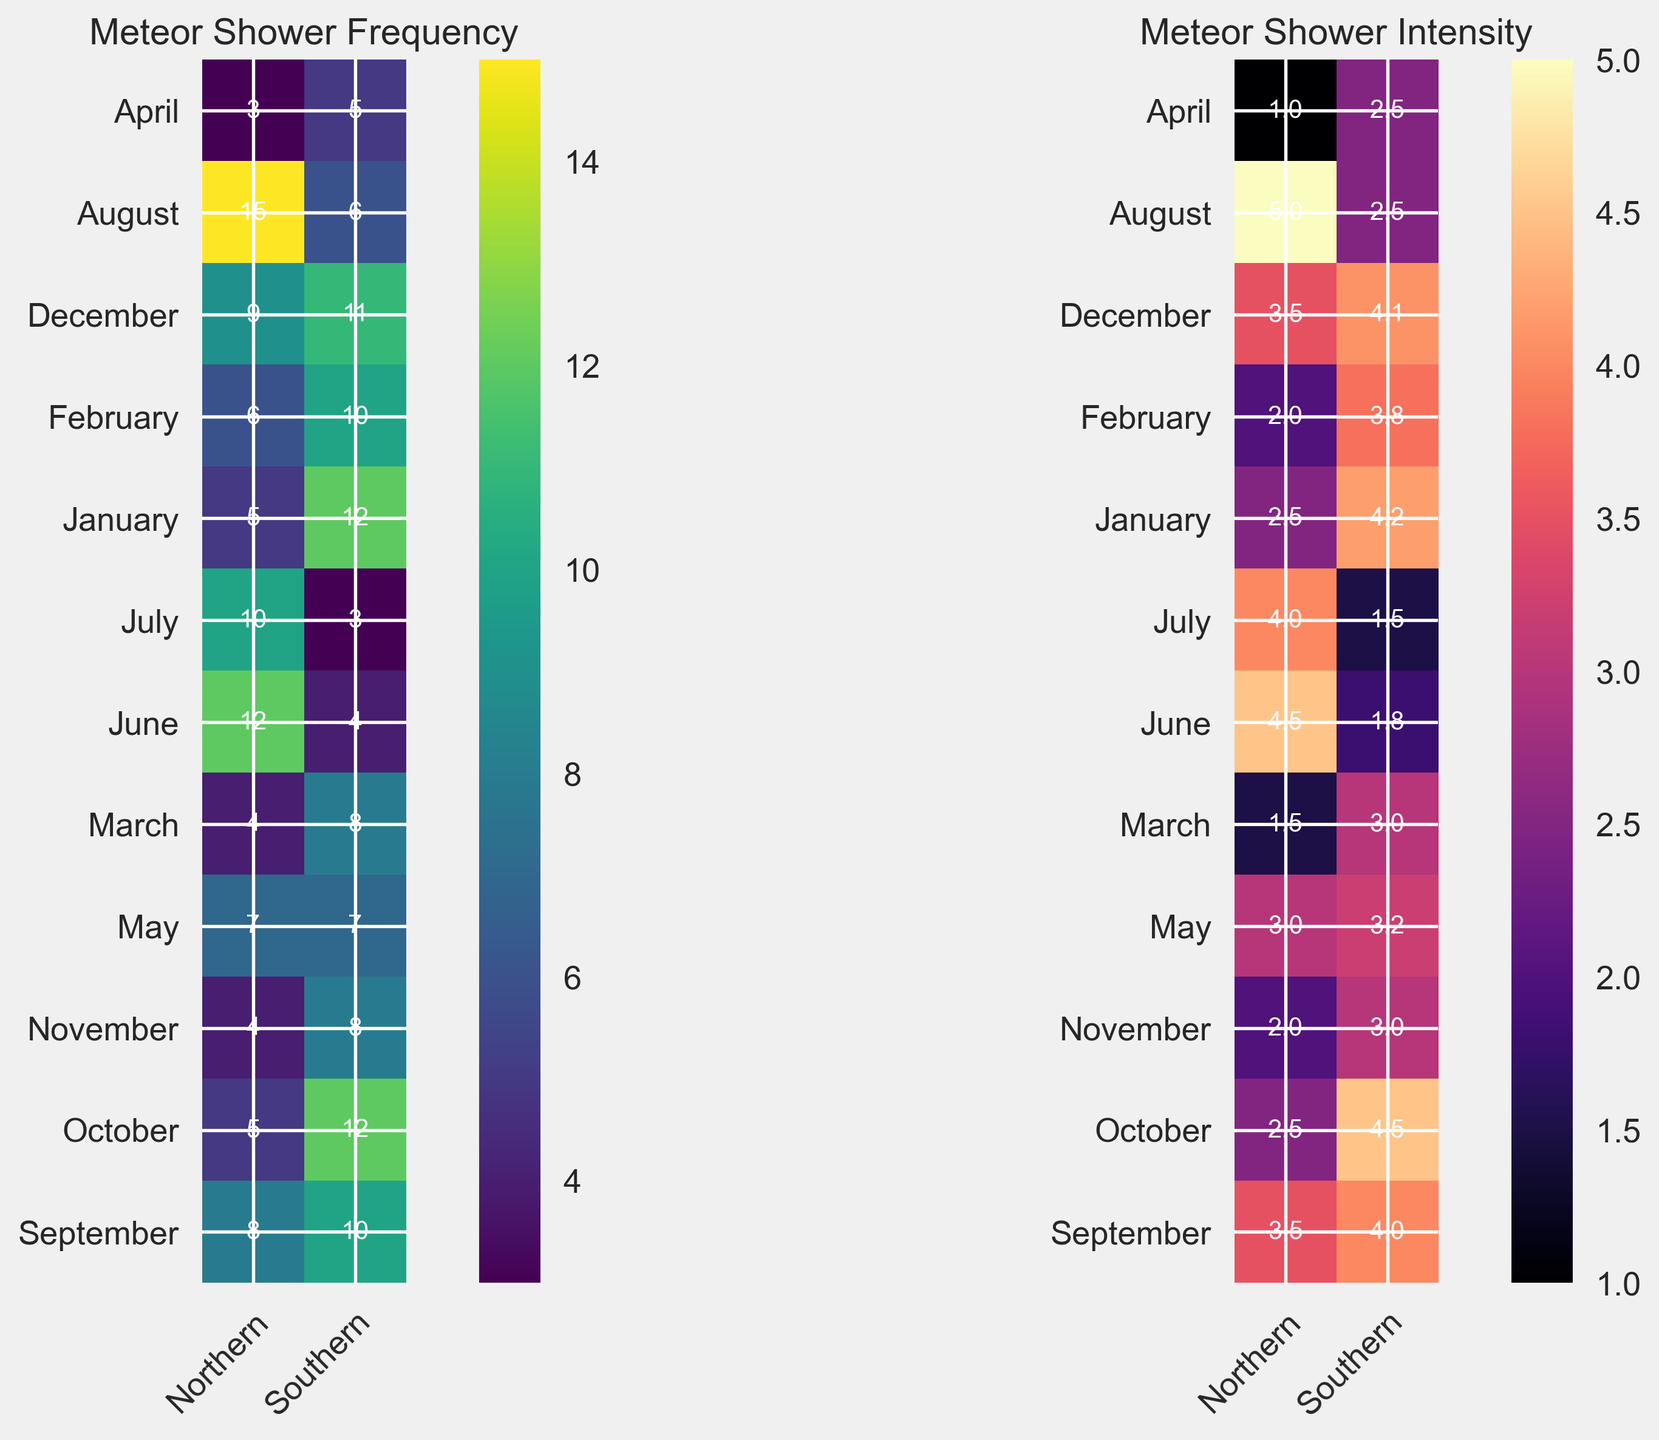Which hemisphere has the highest frequency of meteor showers in August? The Northern Hemisphere has a color block with the highest value in August, whereas the Southern values are lower. Checking the text in the respective blocks, Northern values show 15, and Southern shows 6.
Answer: Northern During which month does the Southern Hemisphere observe the highest meteor shower frequency? The Southern Hemisphere's heatmap has its highest frequency value clearly marked in January and October with a value of 12.
Answer: January and October What is the average intensity of meteor showers in the Northern Hemisphere from June to August inclusive? For the Northern Hemisphere: June (4.5) + July (4.0) + August (5.0) = 13.5, the number of months is 3. The average is 13.5 / 3.
Answer: 4.5 Which month has higher meteor shower frequency in the Northern Hemisphere, July or December? The heatmap shows the values for the Northern Hemisphere in July as 10 and in December as 9. Comparing the two, July has a higher frequency.
Answer: July Is there a month in the Southern Hemisphere where the frequency and intensity have the same value? By observing the heatmap for the Southern Hemisphere, June has both frequency and intensity values close but not exactly equal; closer inspection reveals no exact matches on the values.
Answer: No What is the difference in meteor shower intensity between September and February in the Northern Hemisphere? Northern Hemisphere intensity for September is 3.5 and February is 2.0. The difference is 3.5 - 2.0.
Answer: 1.5 Which hemisphere generally experiences higher meteor shower intensity in March, and what is the intensity difference? Northern Hemisphere intensity in March is 1.5 and Southern Hemisphere is 3.0. The Southern is higher. The difference is 3.0 - 1.5.
Answer: Southern, 1.5 What's the total frequency of meteor showers across both hemispheres in April? Northern Hemisphere: 3, Southern Hemisphere: 5. Thus, the total is 3 + 5.
Answer: 8 Looking at intensity, which month has the most intense meteor showers in the Southern Hemisphere? The heatmap's darkest color for intensity in the Southern Hemisphere corresponds to October with the value marked as 4.5.
Answer: October How does the intensity of meteor showers in January compare between the two hemispheres? January values for intensity are 2.5 for Northern and 4.2 for Southern as indicated on the heatmap. Southern Hemisphere has a higher intensity.
Answer: Southern 